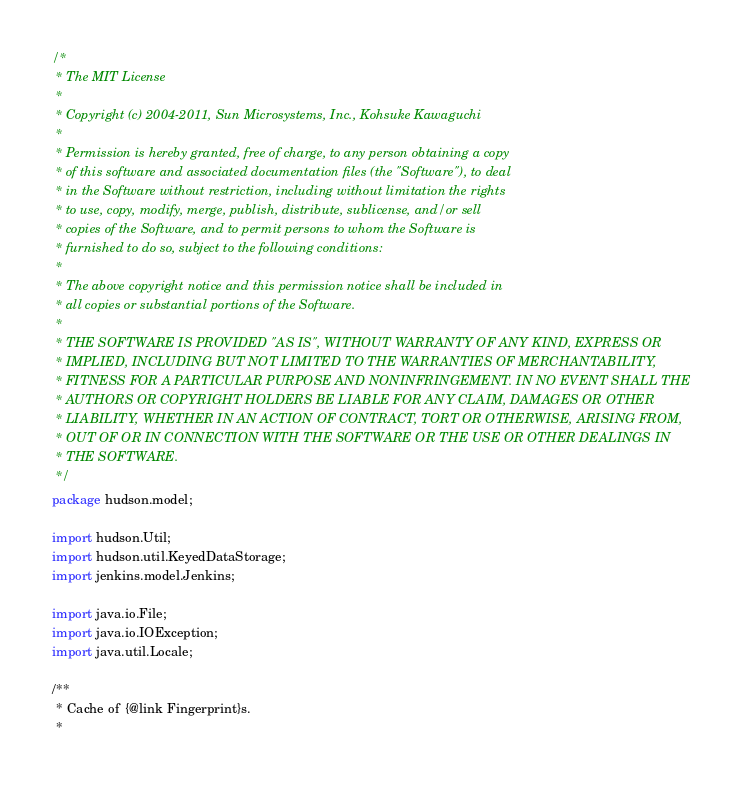Convert code to text. <code><loc_0><loc_0><loc_500><loc_500><_Java_>/*
 * The MIT License
 * 
 * Copyright (c) 2004-2011, Sun Microsystems, Inc., Kohsuke Kawaguchi
 * 
 * Permission is hereby granted, free of charge, to any person obtaining a copy
 * of this software and associated documentation files (the "Software"), to deal
 * in the Software without restriction, including without limitation the rights
 * to use, copy, modify, merge, publish, distribute, sublicense, and/or sell
 * copies of the Software, and to permit persons to whom the Software is
 * furnished to do so, subject to the following conditions:
 * 
 * The above copyright notice and this permission notice shall be included in
 * all copies or substantial portions of the Software.
 * 
 * THE SOFTWARE IS PROVIDED "AS IS", WITHOUT WARRANTY OF ANY KIND, EXPRESS OR
 * IMPLIED, INCLUDING BUT NOT LIMITED TO THE WARRANTIES OF MERCHANTABILITY,
 * FITNESS FOR A PARTICULAR PURPOSE AND NONINFRINGEMENT. IN NO EVENT SHALL THE
 * AUTHORS OR COPYRIGHT HOLDERS BE LIABLE FOR ANY CLAIM, DAMAGES OR OTHER
 * LIABILITY, WHETHER IN AN ACTION OF CONTRACT, TORT OR OTHERWISE, ARISING FROM,
 * OUT OF OR IN CONNECTION WITH THE SOFTWARE OR THE USE OR OTHER DEALINGS IN
 * THE SOFTWARE.
 */
package hudson.model;

import hudson.Util;
import hudson.util.KeyedDataStorage;
import jenkins.model.Jenkins;

import java.io.File;
import java.io.IOException;
import java.util.Locale;

/**
 * Cache of {@link Fingerprint}s.
 *</code> 